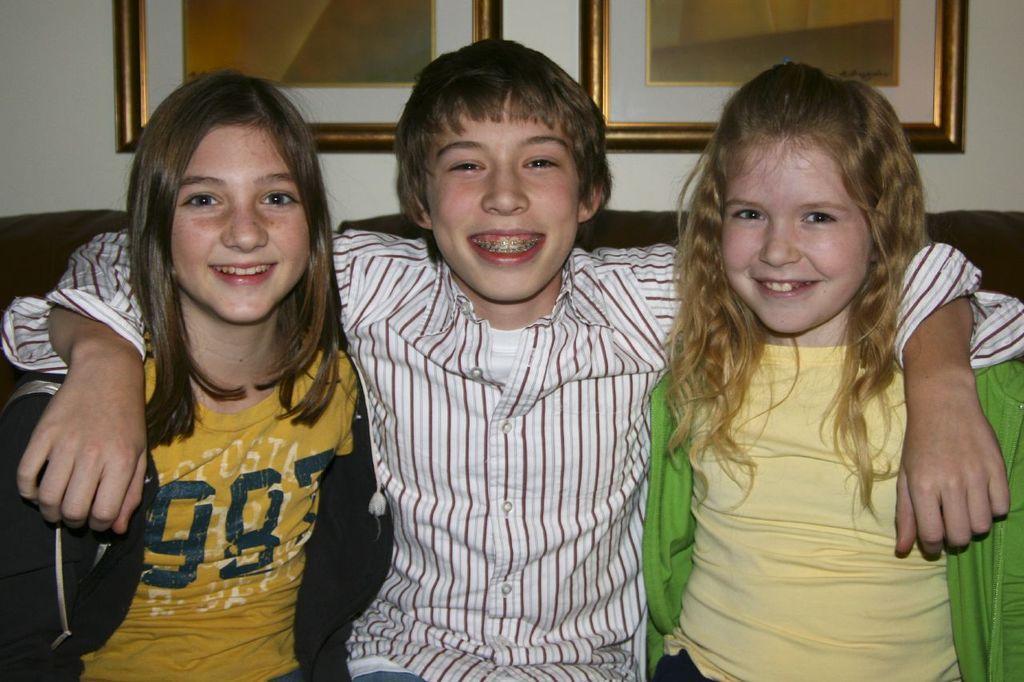How would you summarize this image in a sentence or two? In this image we can see three people sitting and smiling. In the background there is a wall and we can see frames placed on the wall. 